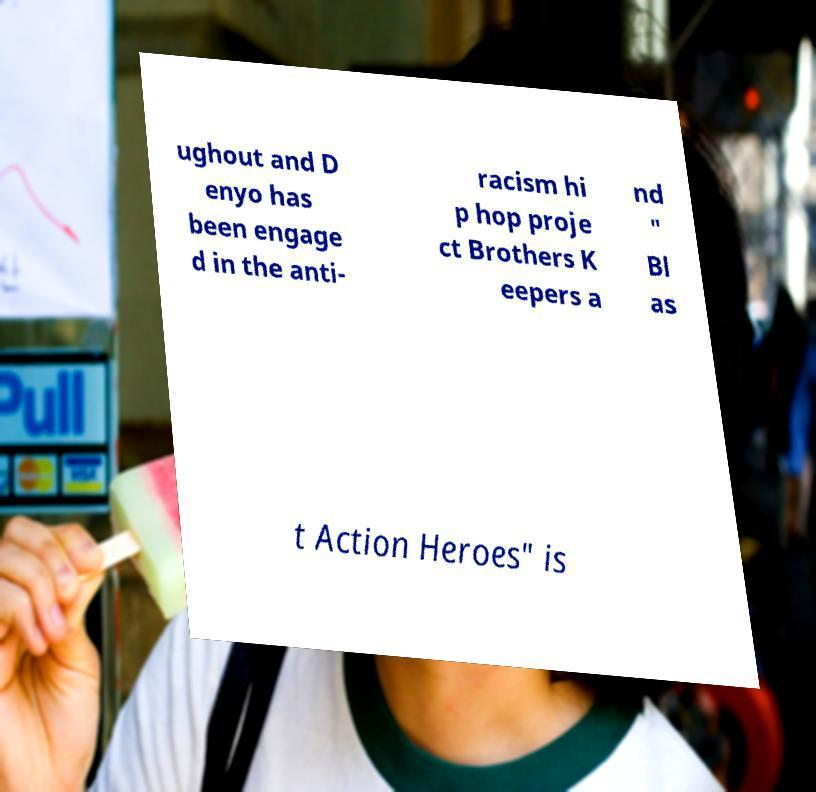For documentation purposes, I need the text within this image transcribed. Could you provide that? ughout and D enyo has been engage d in the anti- racism hi p hop proje ct Brothers K eepers a nd " Bl as t Action Heroes" is 